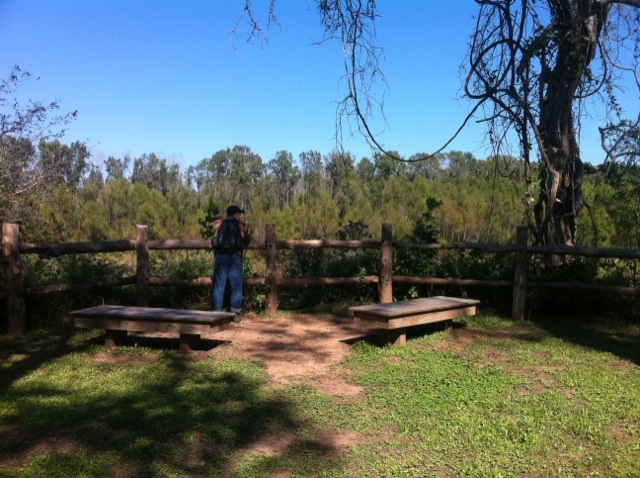Describe the objects in this image and their specific colors. I can see bench in gray and black tones, bench in gray, black, darkgray, and maroon tones, people in gray, black, navy, and darkblue tones, and backpack in gray, black, and maroon tones in this image. 